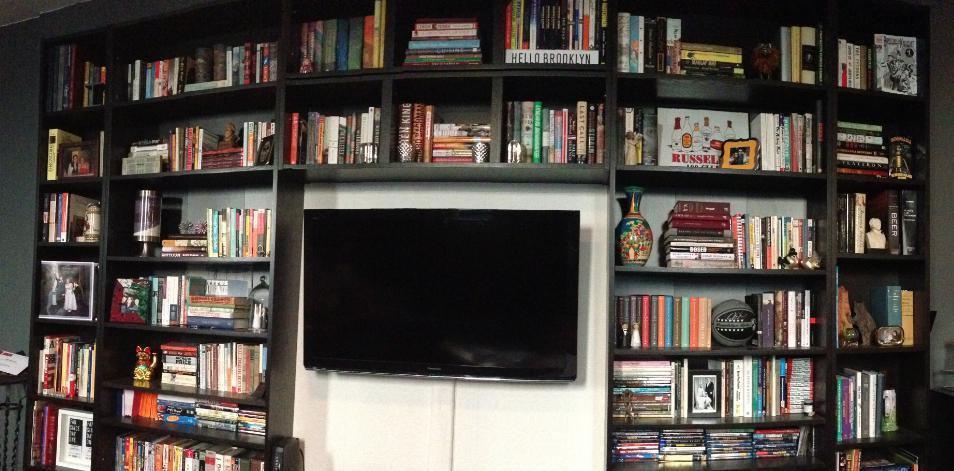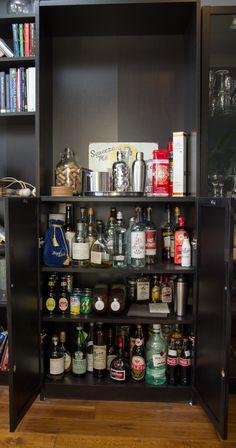The first image is the image on the left, the second image is the image on the right. Examine the images to the left and right. Is the description "in at least one image in the middle of a dark wall bookshelf is a wide tv." accurate? Answer yes or no. Yes. The first image is the image on the left, the second image is the image on the right. For the images displayed, is the sentence "A lamp is on in one of the images." factually correct? Answer yes or no. No. 